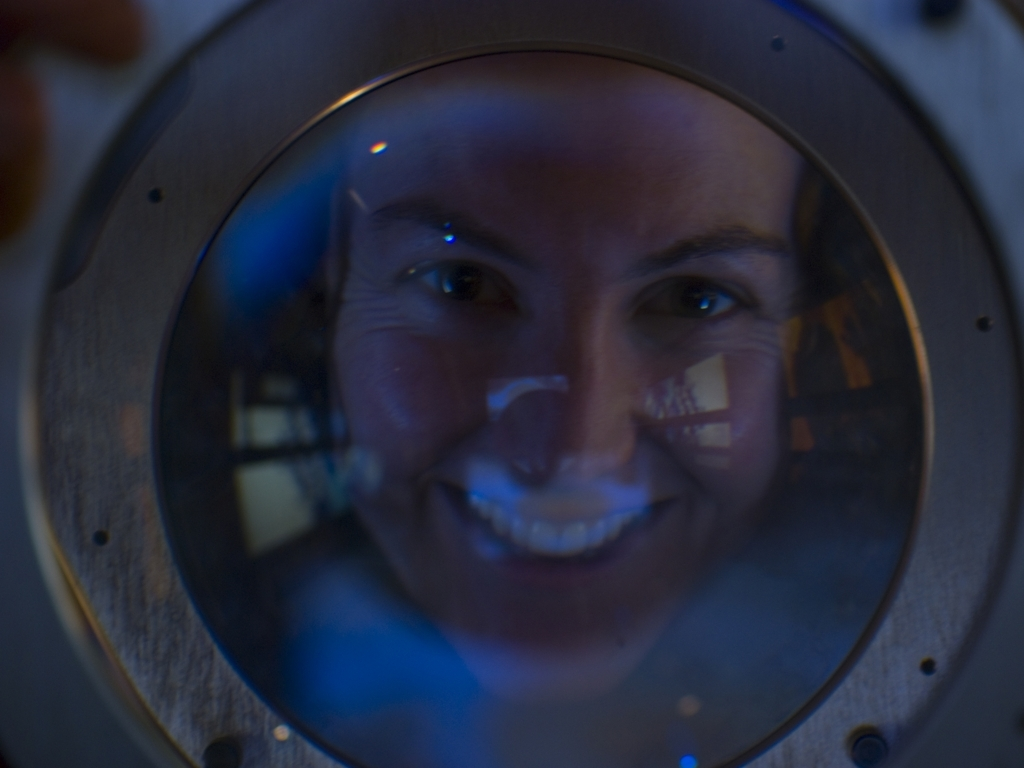Can you describe the person's expression in this image? The person in the image appears to have a gentle, positive expression with a hint of a smile. Their eyes seem to reflect a calm and composed demeanor. Does the expression tell us anything about the context of the image? While the expression is open to interpretation, it could suggest that the individual is experiencing a moment of discovery or engaging with something that brings them joy or satisfaction. The overall setting may be linked to a scientific or exploratory environment, considering the circular window or portal. 